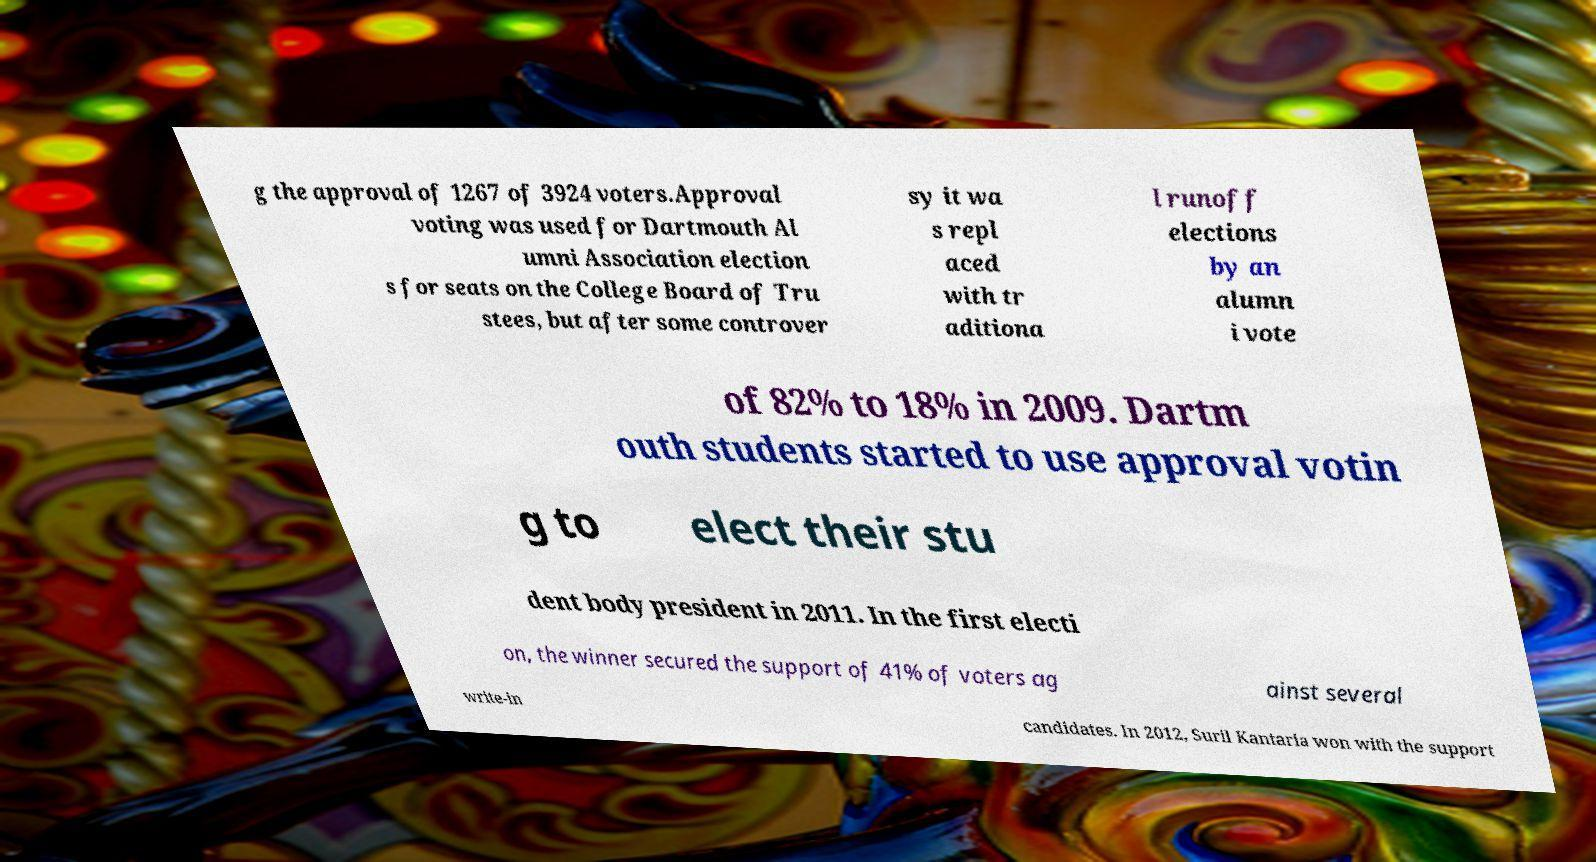Please identify and transcribe the text found in this image. g the approval of 1267 of 3924 voters.Approval voting was used for Dartmouth Al umni Association election s for seats on the College Board of Tru stees, but after some controver sy it wa s repl aced with tr aditiona l runoff elections by an alumn i vote of 82% to 18% in 2009. Dartm outh students started to use approval votin g to elect their stu dent body president in 2011. In the first electi on, the winner secured the support of 41% of voters ag ainst several write-in candidates. In 2012, Suril Kantaria won with the support 